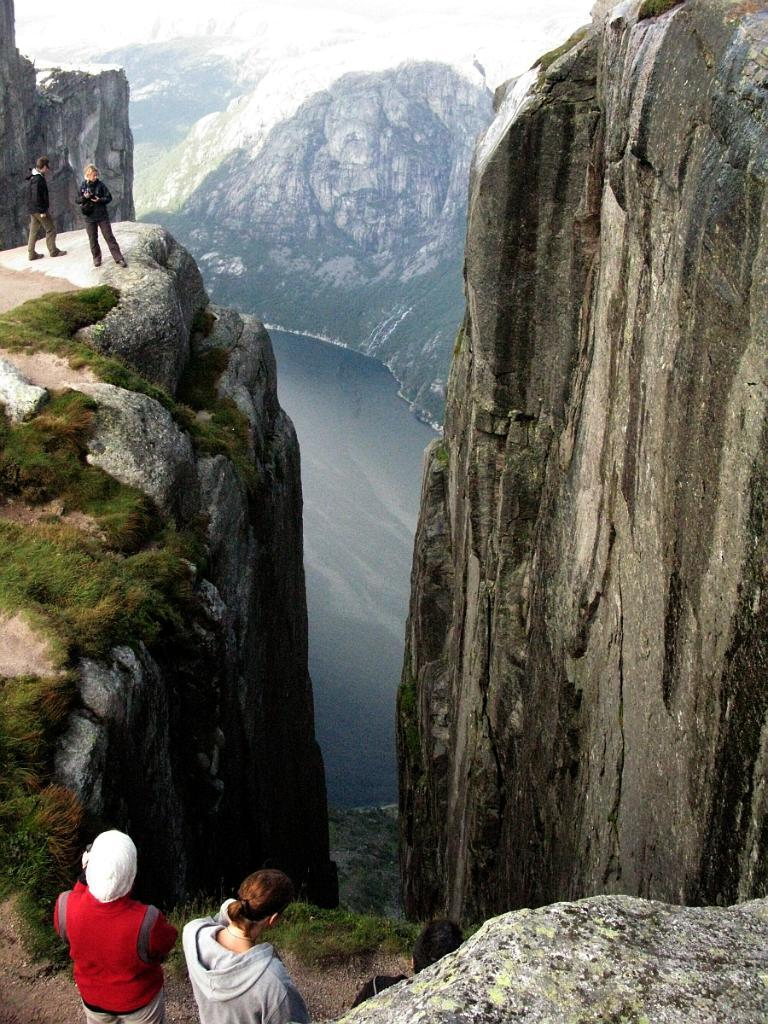What are the people in the image doing? The people are standing on the top edge of a rock. What is located near the rock? There is water near the rock. What can be seen in the distance in the image? There are mountains in the background of the image. What type of square can be seen in the image? There is no square present in the image. What mode of transport can be seen in the image? There is no transport visible in the image. 